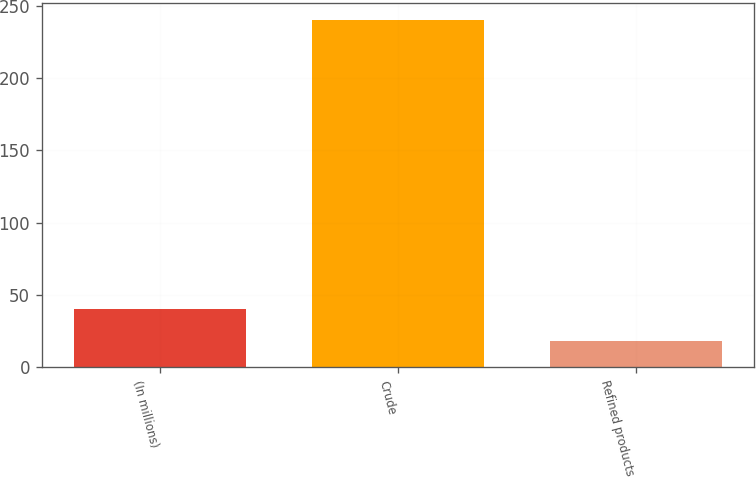Convert chart to OTSL. <chart><loc_0><loc_0><loc_500><loc_500><bar_chart><fcel>(In millions)<fcel>Crude<fcel>Refined products<nl><fcel>40.2<fcel>240<fcel>18<nl></chart> 